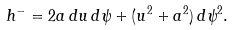Convert formula to latex. <formula><loc_0><loc_0><loc_500><loc_500>h ^ { - } = 2 a \, d u \, d \psi + ( u ^ { 2 } + a ^ { 2 } ) \, d \psi ^ { 2 } .</formula> 